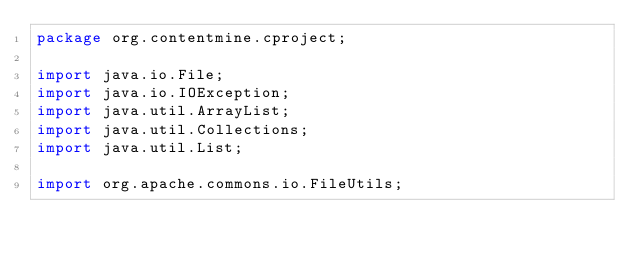Convert code to text. <code><loc_0><loc_0><loc_500><loc_500><_Java_>package org.contentmine.cproject;

import java.io.File;
import java.io.IOException;
import java.util.ArrayList;
import java.util.Collections;
import java.util.List;

import org.apache.commons.io.FileUtils;</code> 